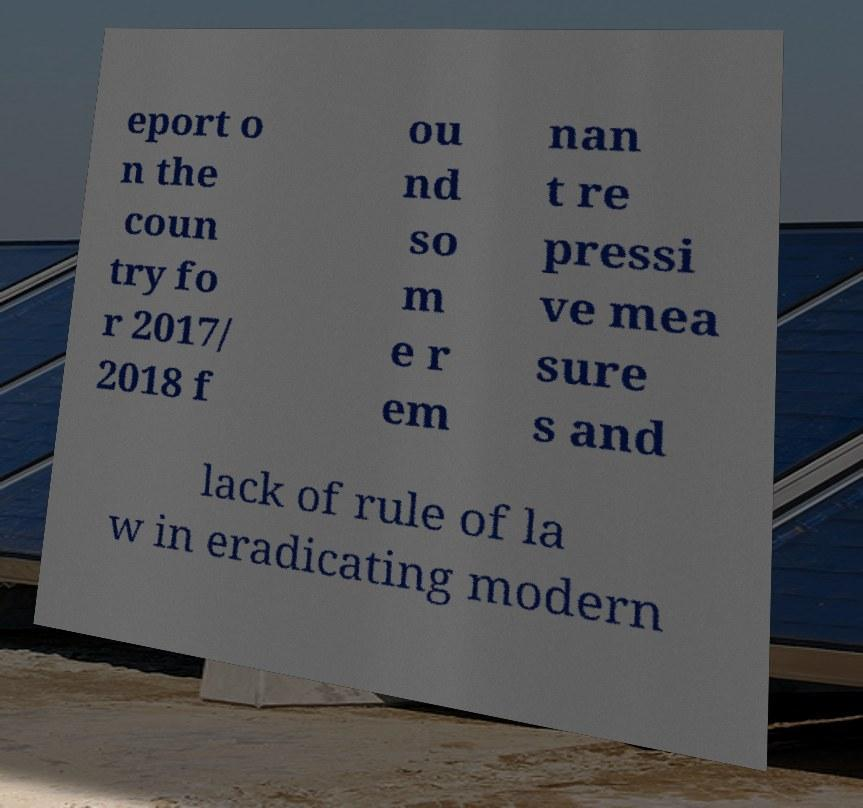There's text embedded in this image that I need extracted. Can you transcribe it verbatim? eport o n the coun try fo r 2017/ 2018 f ou nd so m e r em nan t re pressi ve mea sure s and lack of rule of la w in eradicating modern 